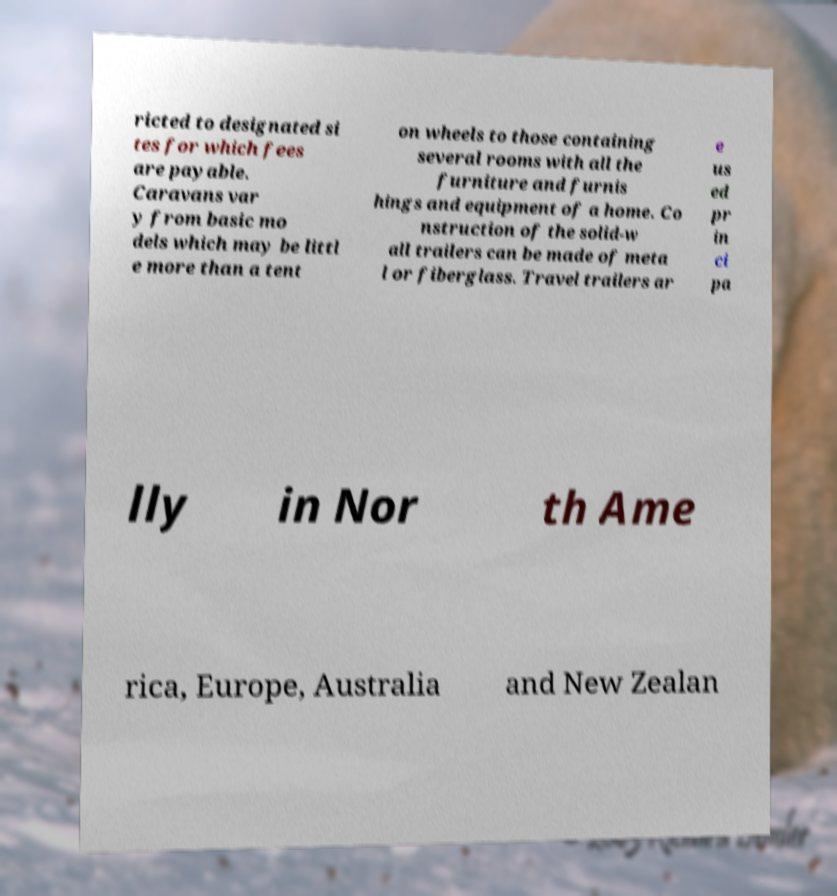Could you extract and type out the text from this image? ricted to designated si tes for which fees are payable. Caravans var y from basic mo dels which may be littl e more than a tent on wheels to those containing several rooms with all the furniture and furnis hings and equipment of a home. Co nstruction of the solid-w all trailers can be made of meta l or fiberglass. Travel trailers ar e us ed pr in ci pa lly in Nor th Ame rica, Europe, Australia and New Zealan 